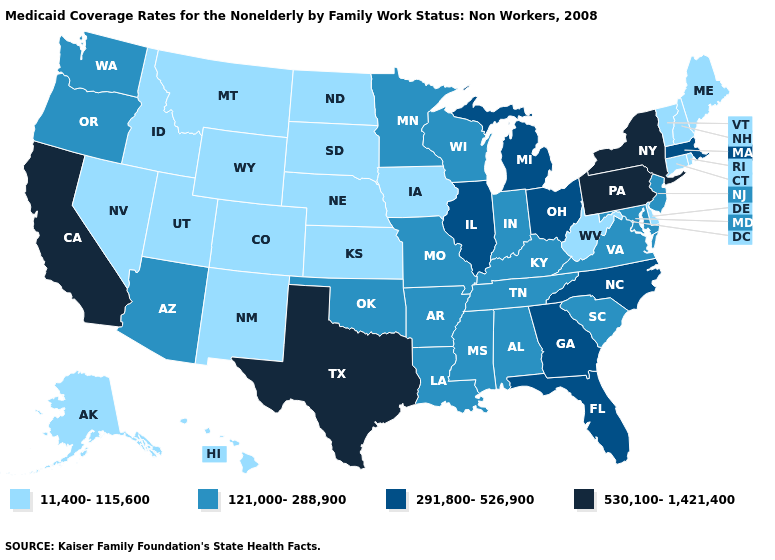Name the states that have a value in the range 291,800-526,900?
Be succinct. Florida, Georgia, Illinois, Massachusetts, Michigan, North Carolina, Ohio. What is the value of Delaware?
Short answer required. 11,400-115,600. Does Tennessee have the same value as Indiana?
Be succinct. Yes. Among the states that border Wisconsin , does Illinois have the highest value?
Keep it brief. Yes. What is the value of Iowa?
Short answer required. 11,400-115,600. What is the value of Ohio?
Be succinct. 291,800-526,900. Among the states that border Utah , which have the highest value?
Short answer required. Arizona. Name the states that have a value in the range 11,400-115,600?
Be succinct. Alaska, Colorado, Connecticut, Delaware, Hawaii, Idaho, Iowa, Kansas, Maine, Montana, Nebraska, Nevada, New Hampshire, New Mexico, North Dakota, Rhode Island, South Dakota, Utah, Vermont, West Virginia, Wyoming. Name the states that have a value in the range 291,800-526,900?
Quick response, please. Florida, Georgia, Illinois, Massachusetts, Michigan, North Carolina, Ohio. Among the states that border Alabama , does Tennessee have the highest value?
Short answer required. No. What is the value of Oklahoma?
Keep it brief. 121,000-288,900. What is the value of West Virginia?
Be succinct. 11,400-115,600. Name the states that have a value in the range 11,400-115,600?
Quick response, please. Alaska, Colorado, Connecticut, Delaware, Hawaii, Idaho, Iowa, Kansas, Maine, Montana, Nebraska, Nevada, New Hampshire, New Mexico, North Dakota, Rhode Island, South Dakota, Utah, Vermont, West Virginia, Wyoming. Name the states that have a value in the range 530,100-1,421,400?
Give a very brief answer. California, New York, Pennsylvania, Texas. 